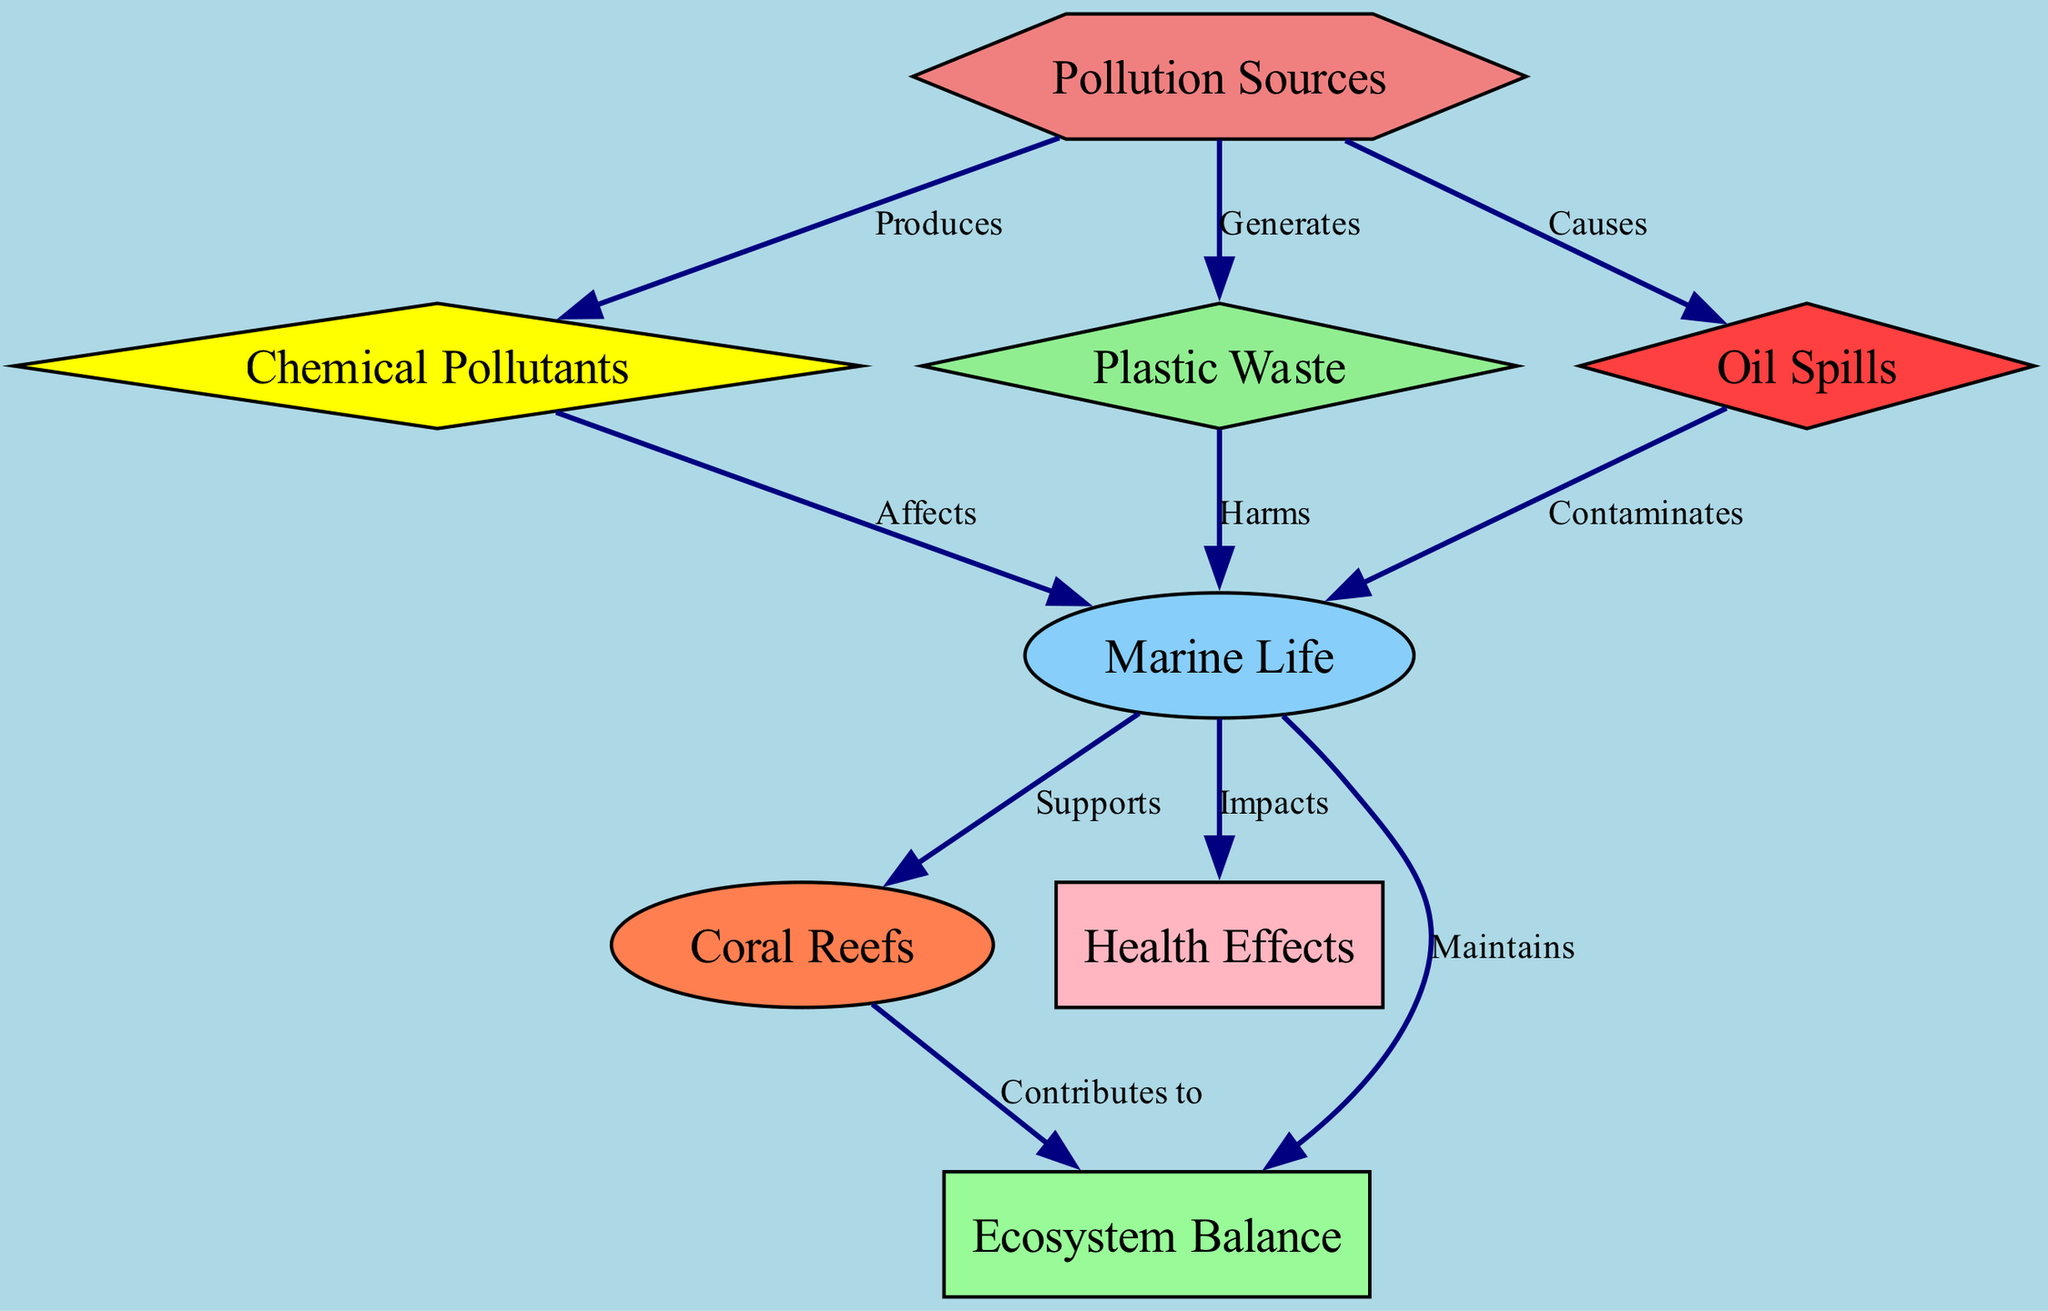What are the pollution sources identified in the diagram? The diagram lists pollution sources such as 'Chemical Pollutants', 'Plastic Waste', and 'Oil Spills' as the nodes resulting from human activities.
Answer: Chemical Pollutants, Plastic Waste, Oil Spills How many nodes are present in the diagram? The diagram contains a total of eight nodes representing different aspects of marine pollution and its impact on marine life.
Answer: Eight What does 'Chemical Pollutants' affect? According to the diagram, 'Chemical Pollutants' directly affects 'Marine Life', as shown by the directed edge connecting these two nodes.
Answer: Marine Life What is the relationship between 'Plastic Waste' and 'Marine Life'? The diagram indicates that 'Plastic Waste' 'Harms' 'Marine Life', also visualized by the directed edge linking the two nodes with the label 'Harms'.
Answer: Harms How does 'Marine Life' contribute to 'Ecosystem Balance'? The diagram shows that 'Marine Life' 'Maintains' the 'Ecosystem Balance', illustrating a direct link from 'Marine Life' to 'Ecosystem Balance' with the label 'Maintains'.
Answer: Maintains What consequence do 'Oil Spills' have on 'Marine Life'? The relationship illustrated clearly states that 'Oil Spills' 'Contaminate' 'Marine Life', demonstrating a negative impact through a directed edge in the diagram.
Answer: Contaminates Which node shows a connection to 'Coral Reefs'? The diagram indicates that 'Marine Life' 'Supports' 'Coral Reefs', establishing the importance of marine species to coral ecosystems via a directed edge.
Answer: Marine Life What impact does 'Marine Life' have on 'Health Effects'? The diagram states that 'Marine Life' 'Impacts' 'Health Effects', demonstrating a direct connection in which the wellbeing of marine organisms influences their health.
Answer: Impacts 